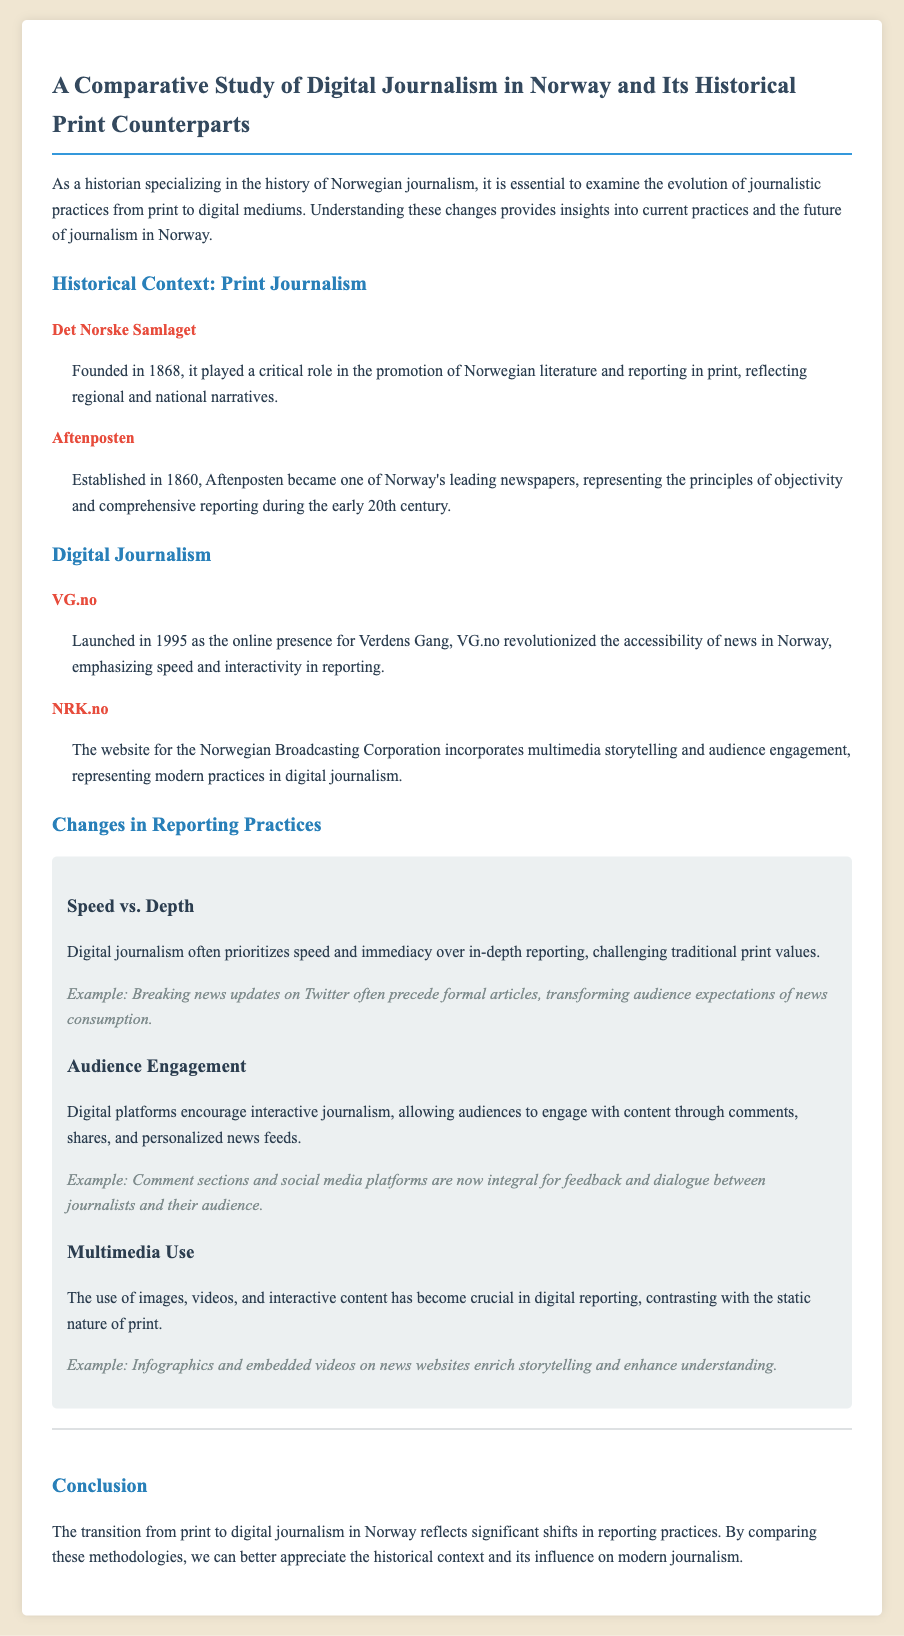What year was Det Norske Samlaget founded? The year founded is specifically mentioned in the historical context section of the document.
Answer: 1868 Who is one of Norway's leading newspapers established in 1860? The document explicitly states Aftenposten's establishment year and its significance in Norwegian journalism.
Answer: Aftenposten What primary emphasis does VG.no have in digital journalism? The description of VG.no highlights its key focus, which is stated in the context of digital journalism practices.
Answer: Speed and interactivity What significant shift in reporting practices is discussed in the memo? The changes section analyzes the evolution of reporting practices, referring to aspects of both print and digital journalism.
Answer: Speed vs. Depth What type of journalism does NRK.no represent? The memo refers to NRK.no's incorporation of certain practices, which are described in the digital journalism section.
Answer: Multimedia storytelling Which organization was established in 1868? This entity's founding year and role in journalism are detailed in the historical context section.
Answer: Det Norske Samlaget What is a crucial aspect of digital reporting compared to print? The changes in reporting practices highlight this distinction, emphasizing the evolving nature of journalism.
Answer: Multimedia use What historical significance does Aftenposten hold in Norway? The description of Aftenposten addresses its importance and principles during a particular time.
Answer: Objectivity and comprehensive reporting 